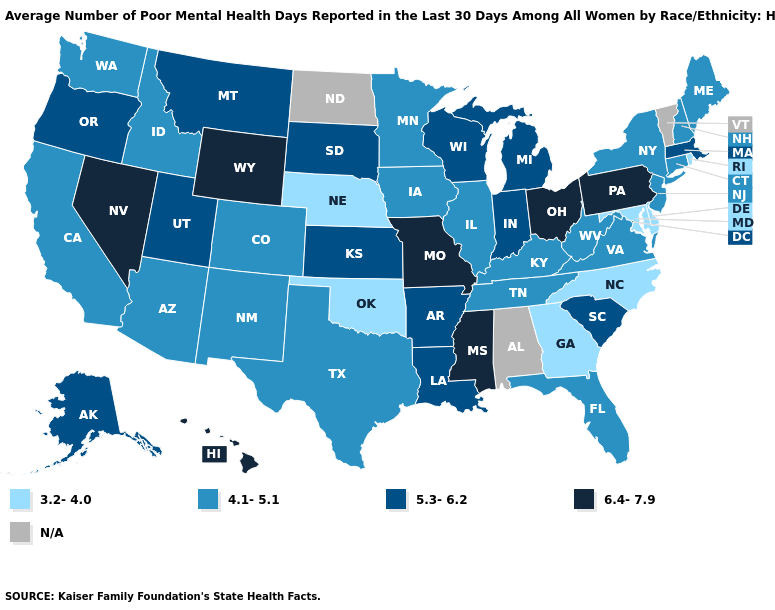Among the states that border North Dakota , does South Dakota have the lowest value?
Write a very short answer. No. What is the highest value in the USA?
Answer briefly. 6.4-7.9. Among the states that border Connecticut , which have the highest value?
Answer briefly. Massachusetts. What is the value of Connecticut?
Keep it brief. 4.1-5.1. What is the value of Georgia?
Give a very brief answer. 3.2-4.0. What is the highest value in the MidWest ?
Keep it brief. 6.4-7.9. How many symbols are there in the legend?
Give a very brief answer. 5. What is the lowest value in the South?
Concise answer only. 3.2-4.0. What is the value of Wyoming?
Give a very brief answer. 6.4-7.9. Does the map have missing data?
Write a very short answer. Yes. Which states have the highest value in the USA?
Answer briefly. Hawaii, Mississippi, Missouri, Nevada, Ohio, Pennsylvania, Wyoming. Among the states that border Colorado , does Wyoming have the highest value?
Quick response, please. Yes. Among the states that border Illinois , which have the lowest value?
Quick response, please. Iowa, Kentucky. Is the legend a continuous bar?
Give a very brief answer. No. 